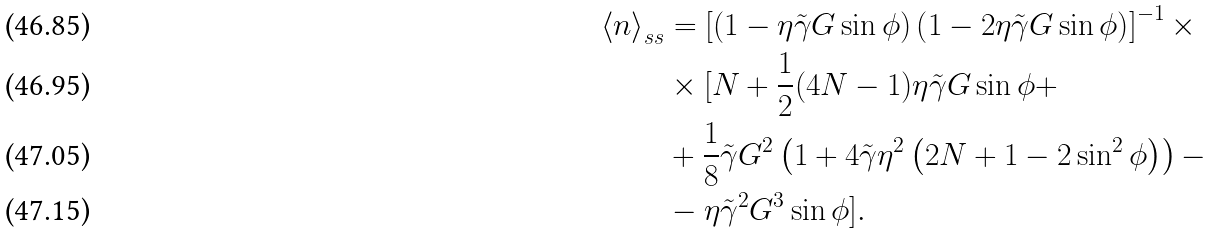<formula> <loc_0><loc_0><loc_500><loc_500>\left \langle n \right \rangle _ { s s } & = \left [ \left ( 1 - \eta \tilde { \gamma } G \sin \phi \right ) \left ( 1 - 2 \eta \tilde { \gamma } G \sin \phi \right ) \right ] ^ { - 1 } \times \\ & \times [ N + \frac { 1 } { 2 } ( 4 N - 1 ) \eta \tilde { \gamma } G \sin \phi + \\ & + \frac { 1 } { 8 } \tilde { \gamma } G ^ { 2 } \left ( 1 + 4 \tilde { \gamma } \eta ^ { 2 } \left ( 2 N + 1 - 2 \sin ^ { 2 } \phi \right ) \right ) - \\ & - \eta \tilde { \gamma } ^ { 2 } G ^ { 3 } \sin \phi ] .</formula> 